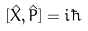<formula> <loc_0><loc_0><loc_500><loc_500>[ { \hat { X } } , { \hat { P } } ] = i \hbar</formula> 